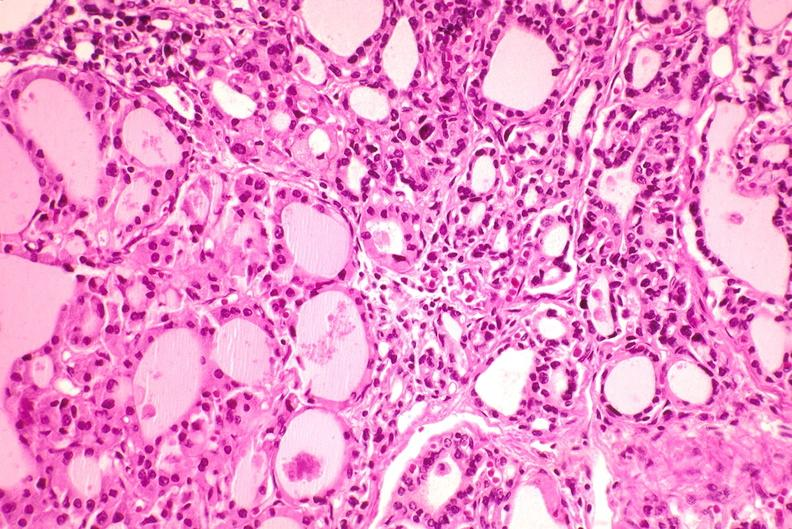s endocrine present?
Answer the question using a single word or phrase. Yes 